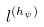<formula> <loc_0><loc_0><loc_500><loc_500>l ^ { ( h _ { \psi } ) }</formula> 